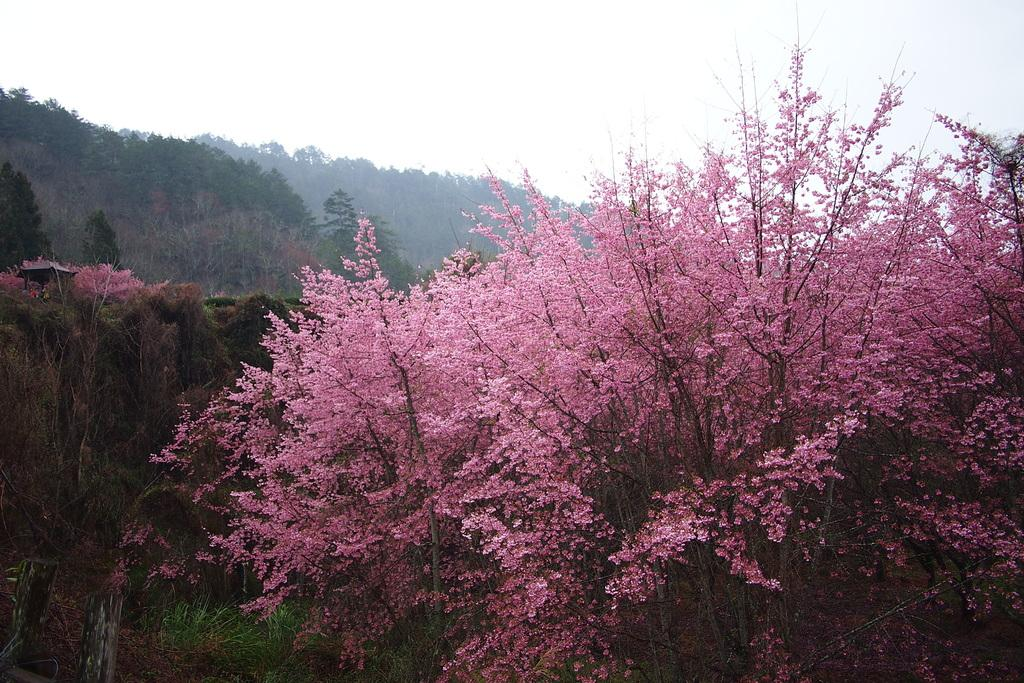What type of plants can be seen in the image? There are flowers in the image. What color are the flowers? The flowers are pink in color. How are the flowers growing in the image? The flowers are grown on trees. What can be seen in the background of the image? There are trees and the sky in the background of the image. What is the condition of the sky in the image? The sky is clear and visible in the background of the image. What type of food is the mother preparing for the family in the image? There is no mother or food preparation present in the image; it features flowers growing on trees. What key is used to unlock the door in the image? There is no door or key present in the image; it features flowers growing on trees. 